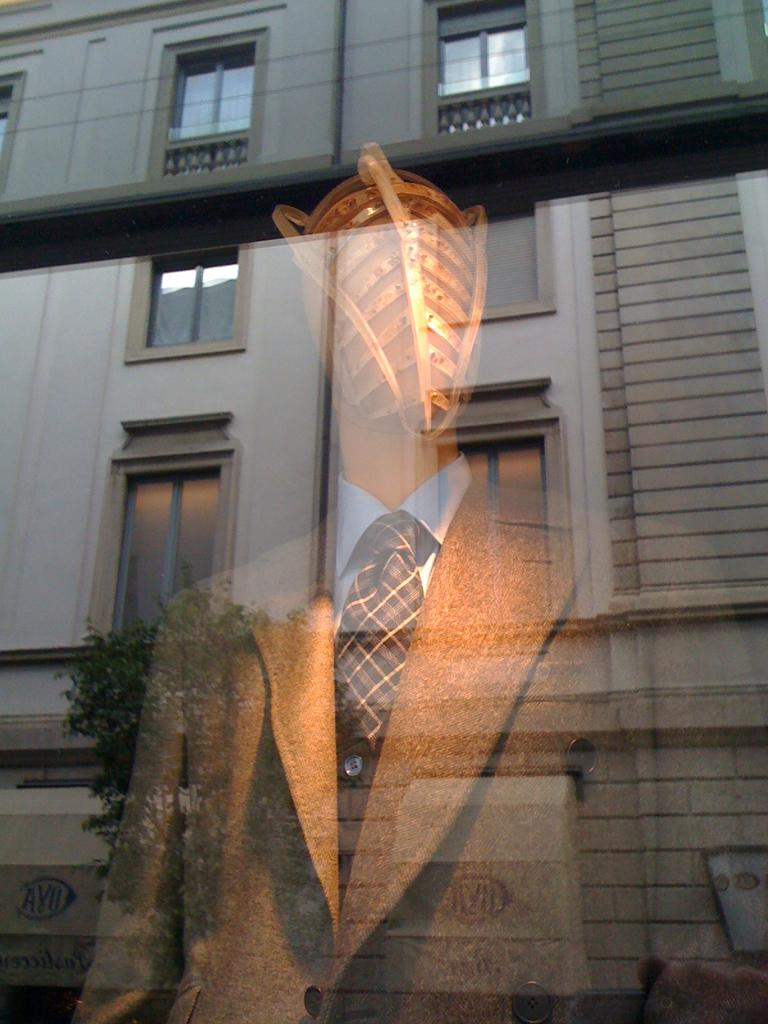What type of structure is present in the picture? There is a building in the picture. What feature can be seen on the building? The building has windows. What natural element is visible in the picture? There is a tree in the picture. What type of object is present in the picture that resembles a human figure? There is a mannequin in the picture. What clothing items is the mannequin wearing? The mannequin is wearing a coat, a tie, and a shirt. What type of stocking can be seen on the tree in the picture? There are no stockings present on the tree in the picture; it is a natural element with leaves and branches. Can you find the receipt for the coat the mannequin is wearing in the picture? There is no receipt visible in the picture, as it is not an item that would be present in the image. 